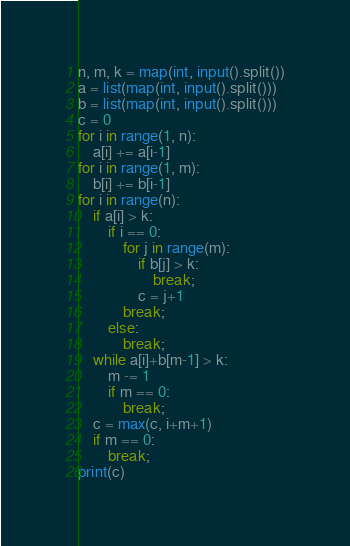Convert code to text. <code><loc_0><loc_0><loc_500><loc_500><_Python_>n, m, k = map(int, input().split())
a = list(map(int, input().split()))
b = list(map(int, input().split()))
c = 0
for i in range(1, n):
    a[i] += a[i-1]
for i in range(1, m):
    b[i] += b[i-1]
for i in range(n):
    if a[i] > k:
        if i == 0:
            for j in range(m):
                if b[j] > k:
                    break;
                c = j+1
            break;
        else:
            break;
    while a[i]+b[m-1] > k:
        m -= 1    
        if m == 0:
            break;
    c = max(c, i+m+1)
    if m == 0:
        break;
print(c)</code> 